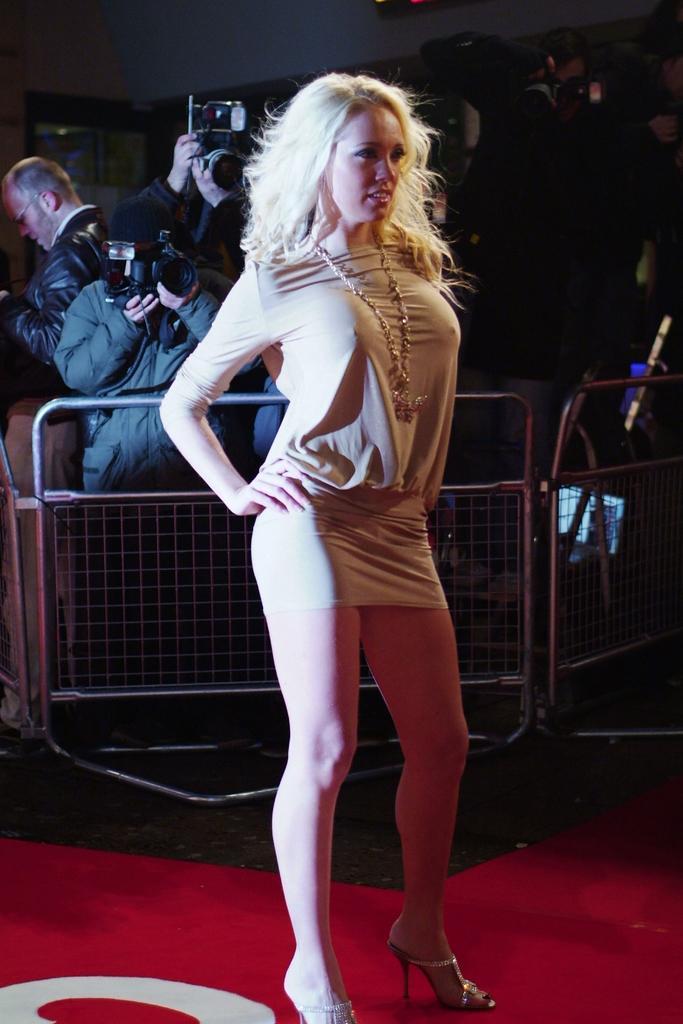Can you describe this image briefly? In this picture I can observe a woman standing on the floor. She is wearing cream color dress. Behind her there is a railing. In the background there are some people holding cameras in their hands. 